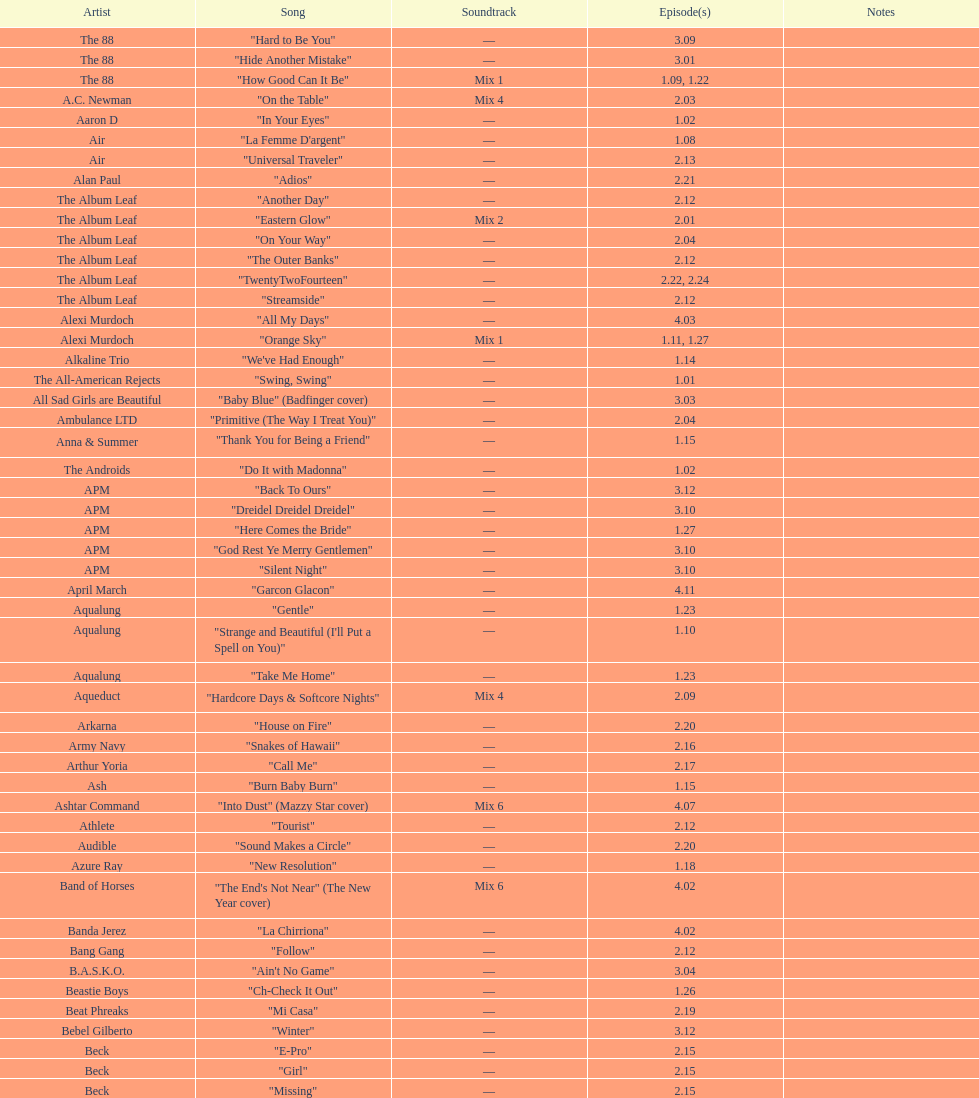Can you name the sole ash track that made an appearance in the o.c.? "Burn Baby Burn". 